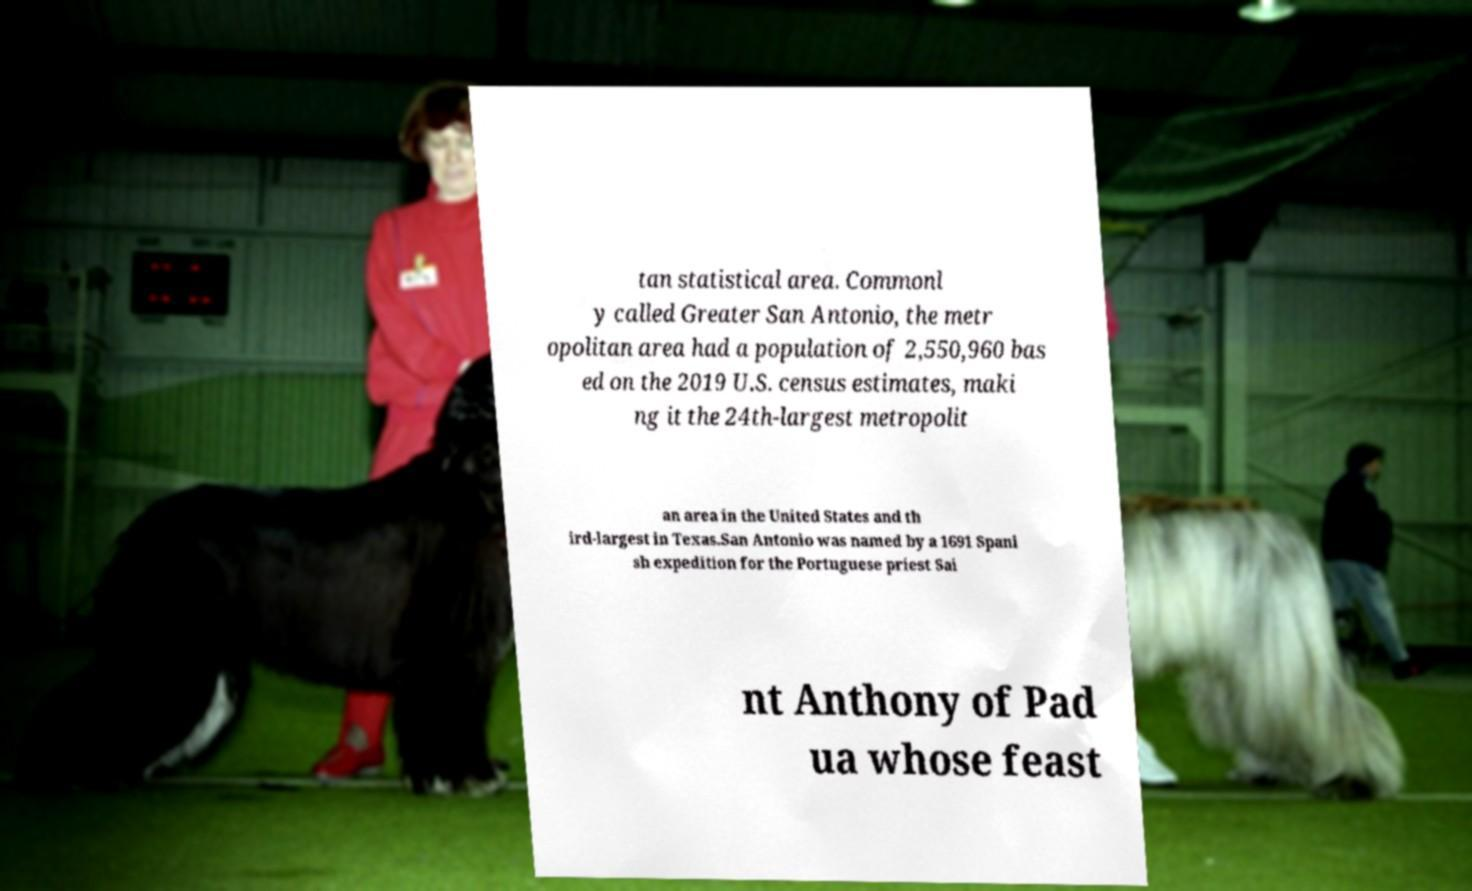I need the written content from this picture converted into text. Can you do that? tan statistical area. Commonl y called Greater San Antonio, the metr opolitan area had a population of 2,550,960 bas ed on the 2019 U.S. census estimates, maki ng it the 24th-largest metropolit an area in the United States and th ird-largest in Texas.San Antonio was named by a 1691 Spani sh expedition for the Portuguese priest Sai nt Anthony of Pad ua whose feast 